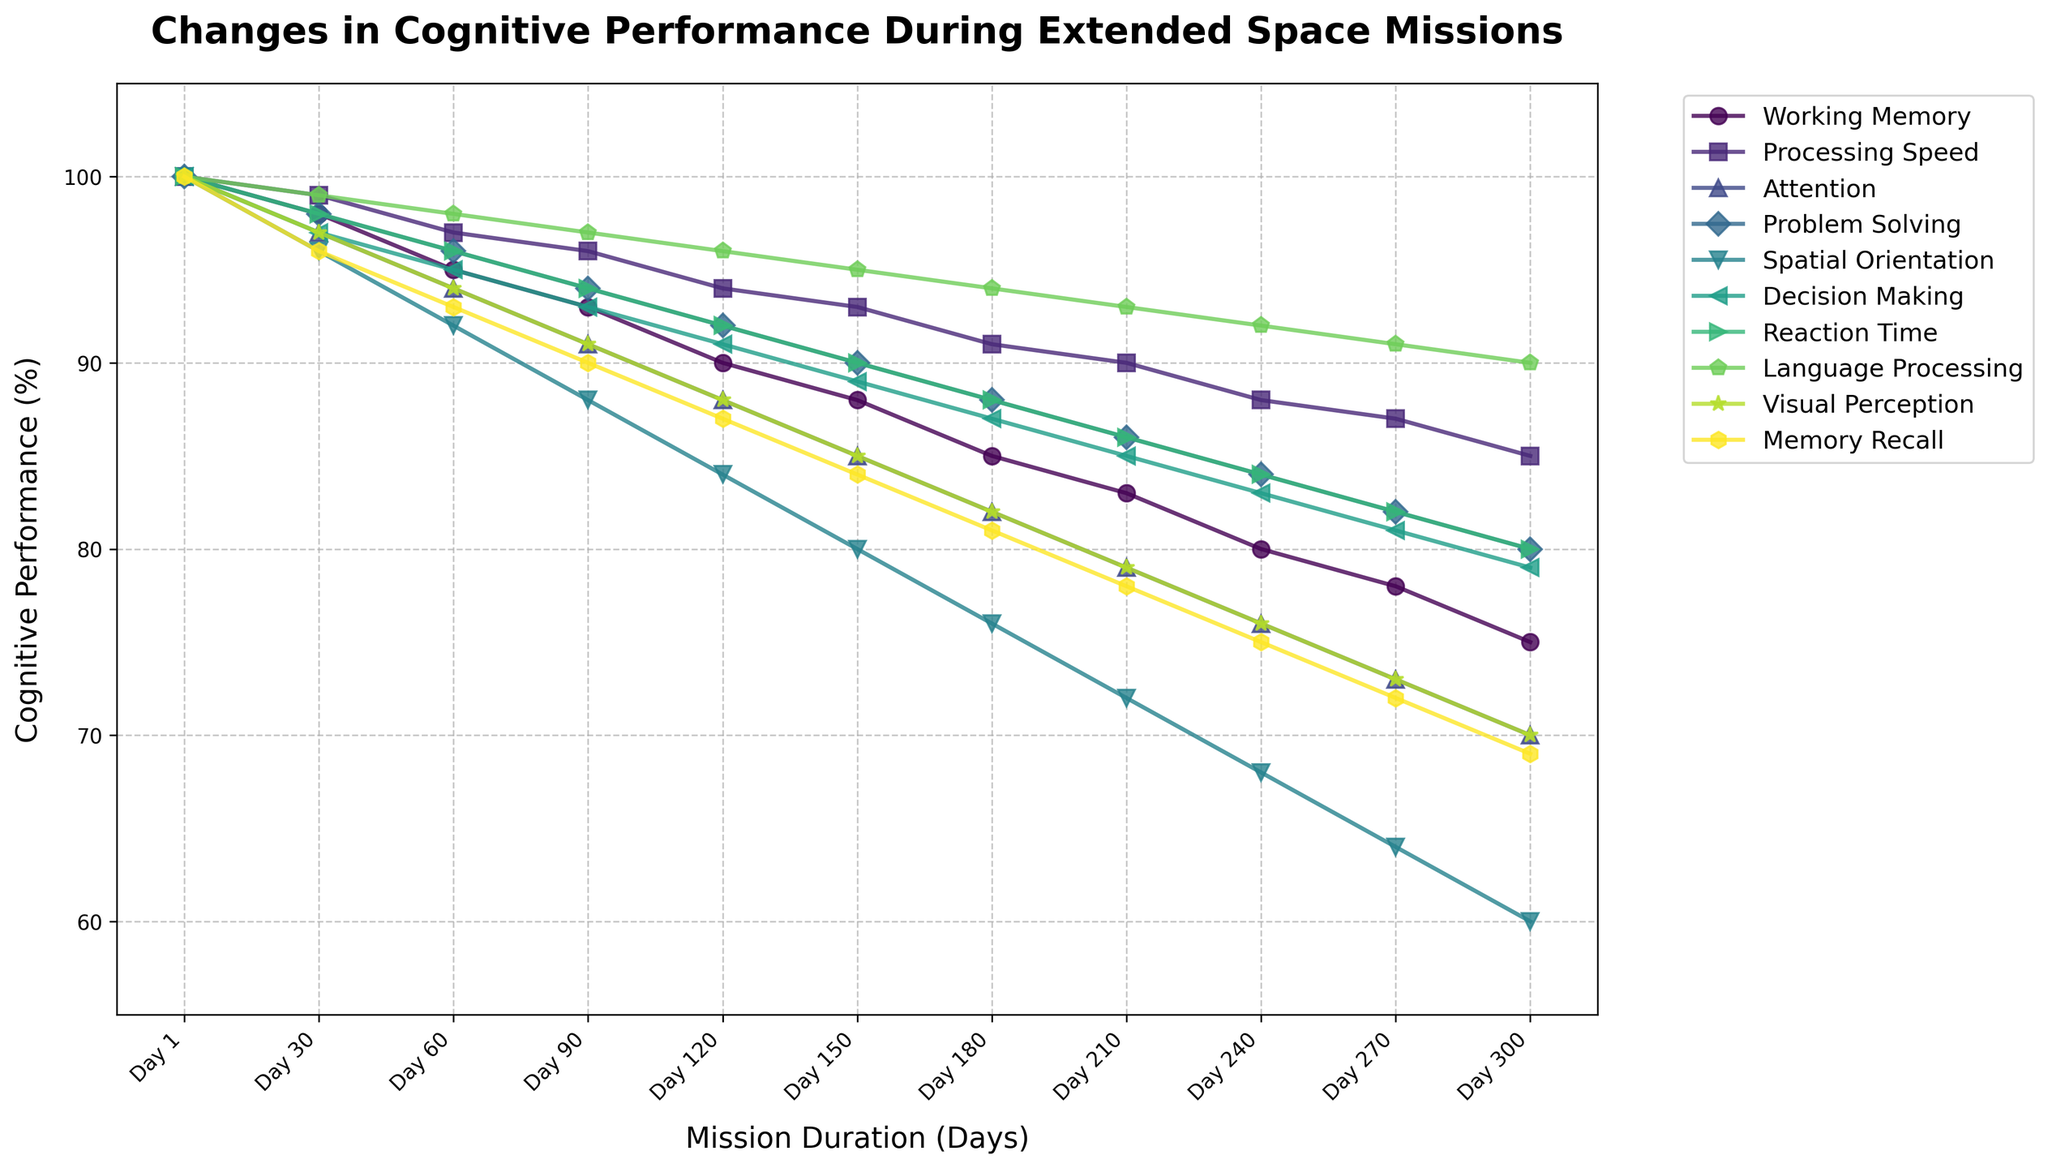Which cognitive task shows the steepest decline in performance from Day 1 to Day 300? To identify the steepest decline, observe the line with the largest drop from Day 1 to Day 300. The Spatial Orientation line drops from 100% to 60%, showing a 40% decline, which is the steepest among all tasks.
Answer: Spatial Orientation Comparing Attention and Processing Speed, which task shows a more significant performance drop by Day 150? Examine both lines at Day 150. Attention drops from 100% to 85% and Processing Speed from 100% to 93%. The difference for Attention is larger (100 - 85 = 15) compared to Processing Speed (100 - 93 = 7).
Answer: Attention What is the average performance of Working Memory over the entire mission duration? List all performance values for Working Memory across the days provided: [100, 98, 95, 93, 90, 88, 85, 83, 80, 78, 75]. Sum these values (100 + 98 + 95 + 93 + 90 + 88 + 85 + 83 + 80 + 78 + 75 = 965) and then divide by the number of values (965 / 11).
Answer: 87.73 By Day 210, which cognitive task has the lowest performance? Compare all cognitive tasks' performance at Day 210. Spatial Orientation has the lowest value, showing a performance of 72%.
Answer: Spatial Orientation What are the three cognitive tasks with the least decline in performance by the end of the mission (Day 300)? Calculate the decline by subtracting the Day 300 value from the Day 1 value for each task. The tasks with the smallest absolute declines are Language Processing (100 - 90 = 10), Processing Speed (100 - 85 = 15), and Reaction Time (100 - 80 = 20).
Answer: Language Processing, Processing Speed, Reaction Time Which three tasks have equal performance on Day 180? Identify tasks with identical values at Day 180 by checking lines at that point. Working Memory, Problem Solving, and Reaction Time each show a performance of 85% on Day 180.
Answer: Working Memory, Problem Solving, Reaction Time Between Days 30 and 240, which task shows the greatest rate of decline? Calculate the decline per day for each task from Day 30 to Day 240 and compare. Spatial Orientation declines from 96% to 64% over 210 days, a rate of (96 - 64) / 210 = 0.1524 per day, which is the greatest.
Answer: Spatial Orientation What is the median performance for all tasks at Day 150? List all performances at Day 150: [88, 93, 85, 90, 80, 89, 90, 95, 85, 84]. The median value is the middle number when these values are ordered: 85, 85, 84, 88, 89, 90, 90, 93, 95. The middle value is 89.
Answer: 89 Which task consistently shows above 90% performance until Day 180? Examine each task's performance over time to see if it stays above 90% until Day 180. Language Processing maintains above 90% throughout this period.
Answer: Language Processing What is the difference in performance between Visual Perception and Memory Recall on Day 300? Look at the Day 300 values for Visual Perception (70%) and Memory Recall (69%). Subtract Memory Recall from Visual Perception (70 - 69).
Answer: 1 